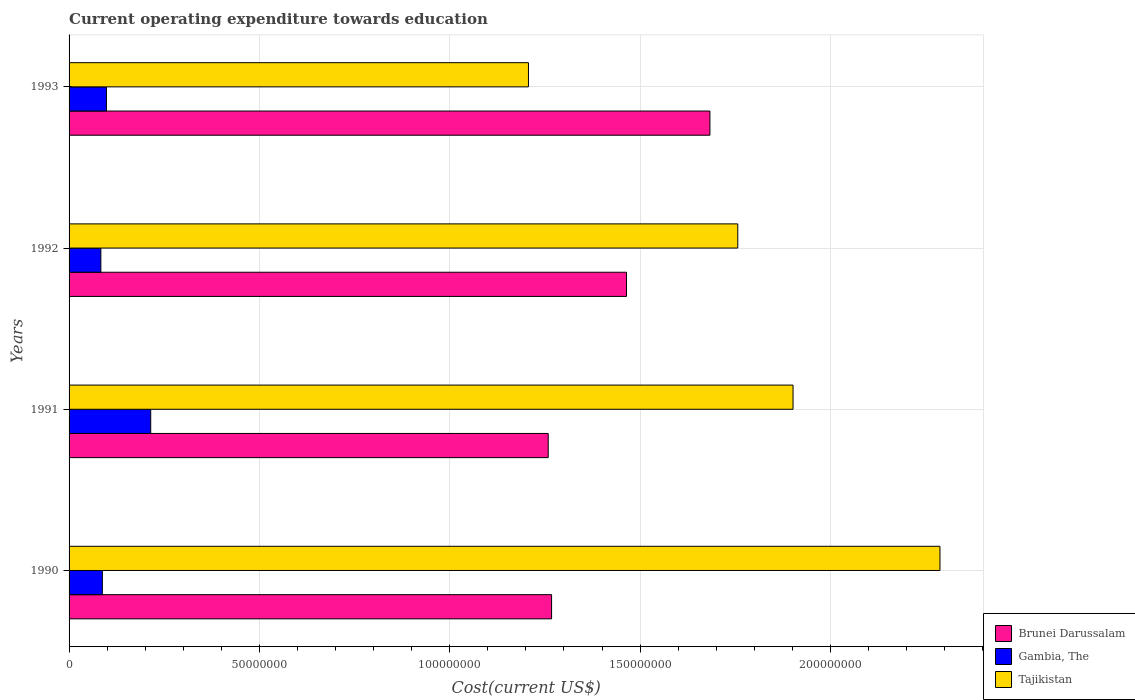What is the label of the 3rd group of bars from the top?
Provide a succinct answer. 1991. What is the expenditure towards education in Gambia, The in 1993?
Keep it short and to the point. 9.81e+06. Across all years, what is the maximum expenditure towards education in Gambia, The?
Provide a succinct answer. 2.14e+07. Across all years, what is the minimum expenditure towards education in Brunei Darussalam?
Offer a very short reply. 1.26e+08. In which year was the expenditure towards education in Brunei Darussalam maximum?
Offer a very short reply. 1993. What is the total expenditure towards education in Tajikistan in the graph?
Make the answer very short. 7.15e+08. What is the difference between the expenditure towards education in Brunei Darussalam in 1991 and that in 1992?
Give a very brief answer. -2.06e+07. What is the difference between the expenditure towards education in Gambia, The in 1992 and the expenditure towards education in Tajikistan in 1991?
Your answer should be very brief. -1.82e+08. What is the average expenditure towards education in Gambia, The per year?
Make the answer very short. 1.21e+07. In the year 1991, what is the difference between the expenditure towards education in Tajikistan and expenditure towards education in Brunei Darussalam?
Give a very brief answer. 6.43e+07. In how many years, is the expenditure towards education in Tajikistan greater than 70000000 US$?
Ensure brevity in your answer.  4. What is the ratio of the expenditure towards education in Brunei Darussalam in 1990 to that in 1991?
Your answer should be compact. 1.01. Is the difference between the expenditure towards education in Tajikistan in 1991 and 1992 greater than the difference between the expenditure towards education in Brunei Darussalam in 1991 and 1992?
Provide a short and direct response. Yes. What is the difference between the highest and the second highest expenditure towards education in Gambia, The?
Make the answer very short. 1.16e+07. What is the difference between the highest and the lowest expenditure towards education in Gambia, The?
Ensure brevity in your answer.  1.31e+07. What does the 1st bar from the top in 1992 represents?
Keep it short and to the point. Tajikistan. What does the 2nd bar from the bottom in 1992 represents?
Ensure brevity in your answer.  Gambia, The. Is it the case that in every year, the sum of the expenditure towards education in Tajikistan and expenditure towards education in Gambia, The is greater than the expenditure towards education in Brunei Darussalam?
Offer a very short reply. No. Does the graph contain any zero values?
Keep it short and to the point. No. Does the graph contain grids?
Keep it short and to the point. Yes. Where does the legend appear in the graph?
Ensure brevity in your answer.  Bottom right. How many legend labels are there?
Your answer should be very brief. 3. What is the title of the graph?
Your response must be concise. Current operating expenditure towards education. Does "Palau" appear as one of the legend labels in the graph?
Offer a very short reply. No. What is the label or title of the X-axis?
Provide a succinct answer. Cost(current US$). What is the Cost(current US$) in Brunei Darussalam in 1990?
Provide a succinct answer. 1.27e+08. What is the Cost(current US$) of Gambia, The in 1990?
Ensure brevity in your answer.  8.75e+06. What is the Cost(current US$) of Tajikistan in 1990?
Provide a succinct answer. 2.29e+08. What is the Cost(current US$) in Brunei Darussalam in 1991?
Your response must be concise. 1.26e+08. What is the Cost(current US$) of Gambia, The in 1991?
Your answer should be compact. 2.14e+07. What is the Cost(current US$) in Tajikistan in 1991?
Your answer should be compact. 1.90e+08. What is the Cost(current US$) in Brunei Darussalam in 1992?
Give a very brief answer. 1.46e+08. What is the Cost(current US$) of Gambia, The in 1992?
Offer a very short reply. 8.35e+06. What is the Cost(current US$) in Tajikistan in 1992?
Your response must be concise. 1.76e+08. What is the Cost(current US$) of Brunei Darussalam in 1993?
Keep it short and to the point. 1.68e+08. What is the Cost(current US$) of Gambia, The in 1993?
Your answer should be very brief. 9.81e+06. What is the Cost(current US$) of Tajikistan in 1993?
Ensure brevity in your answer.  1.21e+08. Across all years, what is the maximum Cost(current US$) in Brunei Darussalam?
Ensure brevity in your answer.  1.68e+08. Across all years, what is the maximum Cost(current US$) in Gambia, The?
Provide a short and direct response. 2.14e+07. Across all years, what is the maximum Cost(current US$) in Tajikistan?
Make the answer very short. 2.29e+08. Across all years, what is the minimum Cost(current US$) in Brunei Darussalam?
Keep it short and to the point. 1.26e+08. Across all years, what is the minimum Cost(current US$) in Gambia, The?
Keep it short and to the point. 8.35e+06. Across all years, what is the minimum Cost(current US$) in Tajikistan?
Offer a very short reply. 1.21e+08. What is the total Cost(current US$) in Brunei Darussalam in the graph?
Your answer should be compact. 5.67e+08. What is the total Cost(current US$) in Gambia, The in the graph?
Provide a succinct answer. 4.84e+07. What is the total Cost(current US$) in Tajikistan in the graph?
Keep it short and to the point. 7.15e+08. What is the difference between the Cost(current US$) of Brunei Darussalam in 1990 and that in 1991?
Offer a very short reply. 8.83e+05. What is the difference between the Cost(current US$) of Gambia, The in 1990 and that in 1991?
Give a very brief answer. -1.27e+07. What is the difference between the Cost(current US$) in Tajikistan in 1990 and that in 1991?
Provide a short and direct response. 3.86e+07. What is the difference between the Cost(current US$) of Brunei Darussalam in 1990 and that in 1992?
Give a very brief answer. -1.97e+07. What is the difference between the Cost(current US$) of Gambia, The in 1990 and that in 1992?
Give a very brief answer. 3.99e+05. What is the difference between the Cost(current US$) of Tajikistan in 1990 and that in 1992?
Make the answer very short. 5.31e+07. What is the difference between the Cost(current US$) in Brunei Darussalam in 1990 and that in 1993?
Keep it short and to the point. -4.16e+07. What is the difference between the Cost(current US$) of Gambia, The in 1990 and that in 1993?
Offer a terse response. -1.07e+06. What is the difference between the Cost(current US$) of Tajikistan in 1990 and that in 1993?
Provide a short and direct response. 1.08e+08. What is the difference between the Cost(current US$) of Brunei Darussalam in 1991 and that in 1992?
Make the answer very short. -2.06e+07. What is the difference between the Cost(current US$) of Gambia, The in 1991 and that in 1992?
Your answer should be very brief. 1.31e+07. What is the difference between the Cost(current US$) in Tajikistan in 1991 and that in 1992?
Provide a short and direct response. 1.45e+07. What is the difference between the Cost(current US$) in Brunei Darussalam in 1991 and that in 1993?
Ensure brevity in your answer.  -4.25e+07. What is the difference between the Cost(current US$) in Gambia, The in 1991 and that in 1993?
Provide a succinct answer. 1.16e+07. What is the difference between the Cost(current US$) of Tajikistan in 1991 and that in 1993?
Your response must be concise. 6.95e+07. What is the difference between the Cost(current US$) in Brunei Darussalam in 1992 and that in 1993?
Provide a short and direct response. -2.19e+07. What is the difference between the Cost(current US$) of Gambia, The in 1992 and that in 1993?
Your answer should be very brief. -1.47e+06. What is the difference between the Cost(current US$) in Tajikistan in 1992 and that in 1993?
Keep it short and to the point. 5.50e+07. What is the difference between the Cost(current US$) in Brunei Darussalam in 1990 and the Cost(current US$) in Gambia, The in 1991?
Give a very brief answer. 1.05e+08. What is the difference between the Cost(current US$) of Brunei Darussalam in 1990 and the Cost(current US$) of Tajikistan in 1991?
Make the answer very short. -6.34e+07. What is the difference between the Cost(current US$) of Gambia, The in 1990 and the Cost(current US$) of Tajikistan in 1991?
Ensure brevity in your answer.  -1.81e+08. What is the difference between the Cost(current US$) in Brunei Darussalam in 1990 and the Cost(current US$) in Gambia, The in 1992?
Your answer should be compact. 1.18e+08. What is the difference between the Cost(current US$) of Brunei Darussalam in 1990 and the Cost(current US$) of Tajikistan in 1992?
Provide a succinct answer. -4.89e+07. What is the difference between the Cost(current US$) of Gambia, The in 1990 and the Cost(current US$) of Tajikistan in 1992?
Offer a very short reply. -1.67e+08. What is the difference between the Cost(current US$) of Brunei Darussalam in 1990 and the Cost(current US$) of Gambia, The in 1993?
Provide a short and direct response. 1.17e+08. What is the difference between the Cost(current US$) of Brunei Darussalam in 1990 and the Cost(current US$) of Tajikistan in 1993?
Ensure brevity in your answer.  6.07e+06. What is the difference between the Cost(current US$) of Gambia, The in 1990 and the Cost(current US$) of Tajikistan in 1993?
Give a very brief answer. -1.12e+08. What is the difference between the Cost(current US$) of Brunei Darussalam in 1991 and the Cost(current US$) of Gambia, The in 1992?
Give a very brief answer. 1.18e+08. What is the difference between the Cost(current US$) in Brunei Darussalam in 1991 and the Cost(current US$) in Tajikistan in 1992?
Offer a terse response. -4.98e+07. What is the difference between the Cost(current US$) of Gambia, The in 1991 and the Cost(current US$) of Tajikistan in 1992?
Your answer should be very brief. -1.54e+08. What is the difference between the Cost(current US$) in Brunei Darussalam in 1991 and the Cost(current US$) in Gambia, The in 1993?
Give a very brief answer. 1.16e+08. What is the difference between the Cost(current US$) in Brunei Darussalam in 1991 and the Cost(current US$) in Tajikistan in 1993?
Your answer should be very brief. 5.19e+06. What is the difference between the Cost(current US$) in Gambia, The in 1991 and the Cost(current US$) in Tajikistan in 1993?
Keep it short and to the point. -9.92e+07. What is the difference between the Cost(current US$) of Brunei Darussalam in 1992 and the Cost(current US$) of Gambia, The in 1993?
Give a very brief answer. 1.37e+08. What is the difference between the Cost(current US$) of Brunei Darussalam in 1992 and the Cost(current US$) of Tajikistan in 1993?
Your answer should be compact. 2.58e+07. What is the difference between the Cost(current US$) in Gambia, The in 1992 and the Cost(current US$) in Tajikistan in 1993?
Offer a very short reply. -1.12e+08. What is the average Cost(current US$) in Brunei Darussalam per year?
Provide a short and direct response. 1.42e+08. What is the average Cost(current US$) in Gambia, The per year?
Your answer should be compact. 1.21e+07. What is the average Cost(current US$) of Tajikistan per year?
Provide a succinct answer. 1.79e+08. In the year 1990, what is the difference between the Cost(current US$) of Brunei Darussalam and Cost(current US$) of Gambia, The?
Your answer should be compact. 1.18e+08. In the year 1990, what is the difference between the Cost(current US$) of Brunei Darussalam and Cost(current US$) of Tajikistan?
Offer a very short reply. -1.02e+08. In the year 1990, what is the difference between the Cost(current US$) of Gambia, The and Cost(current US$) of Tajikistan?
Your answer should be very brief. -2.20e+08. In the year 1991, what is the difference between the Cost(current US$) of Brunei Darussalam and Cost(current US$) of Gambia, The?
Offer a terse response. 1.04e+08. In the year 1991, what is the difference between the Cost(current US$) in Brunei Darussalam and Cost(current US$) in Tajikistan?
Give a very brief answer. -6.43e+07. In the year 1991, what is the difference between the Cost(current US$) in Gambia, The and Cost(current US$) in Tajikistan?
Provide a short and direct response. -1.69e+08. In the year 1992, what is the difference between the Cost(current US$) in Brunei Darussalam and Cost(current US$) in Gambia, The?
Make the answer very short. 1.38e+08. In the year 1992, what is the difference between the Cost(current US$) in Brunei Darussalam and Cost(current US$) in Tajikistan?
Keep it short and to the point. -2.92e+07. In the year 1992, what is the difference between the Cost(current US$) in Gambia, The and Cost(current US$) in Tajikistan?
Provide a short and direct response. -1.67e+08. In the year 1993, what is the difference between the Cost(current US$) in Brunei Darussalam and Cost(current US$) in Gambia, The?
Your response must be concise. 1.59e+08. In the year 1993, what is the difference between the Cost(current US$) of Brunei Darussalam and Cost(current US$) of Tajikistan?
Provide a succinct answer. 4.77e+07. In the year 1993, what is the difference between the Cost(current US$) of Gambia, The and Cost(current US$) of Tajikistan?
Offer a very short reply. -1.11e+08. What is the ratio of the Cost(current US$) in Gambia, The in 1990 to that in 1991?
Give a very brief answer. 0.41. What is the ratio of the Cost(current US$) of Tajikistan in 1990 to that in 1991?
Give a very brief answer. 1.2. What is the ratio of the Cost(current US$) in Brunei Darussalam in 1990 to that in 1992?
Your answer should be compact. 0.87. What is the ratio of the Cost(current US$) of Gambia, The in 1990 to that in 1992?
Keep it short and to the point. 1.05. What is the ratio of the Cost(current US$) of Tajikistan in 1990 to that in 1992?
Offer a very short reply. 1.3. What is the ratio of the Cost(current US$) of Brunei Darussalam in 1990 to that in 1993?
Provide a short and direct response. 0.75. What is the ratio of the Cost(current US$) in Gambia, The in 1990 to that in 1993?
Give a very brief answer. 0.89. What is the ratio of the Cost(current US$) in Tajikistan in 1990 to that in 1993?
Make the answer very short. 1.9. What is the ratio of the Cost(current US$) in Brunei Darussalam in 1991 to that in 1992?
Provide a succinct answer. 0.86. What is the ratio of the Cost(current US$) of Gambia, The in 1991 to that in 1992?
Ensure brevity in your answer.  2.57. What is the ratio of the Cost(current US$) of Tajikistan in 1991 to that in 1992?
Keep it short and to the point. 1.08. What is the ratio of the Cost(current US$) in Brunei Darussalam in 1991 to that in 1993?
Ensure brevity in your answer.  0.75. What is the ratio of the Cost(current US$) of Gambia, The in 1991 to that in 1993?
Ensure brevity in your answer.  2.19. What is the ratio of the Cost(current US$) of Tajikistan in 1991 to that in 1993?
Give a very brief answer. 1.58. What is the ratio of the Cost(current US$) in Brunei Darussalam in 1992 to that in 1993?
Provide a succinct answer. 0.87. What is the ratio of the Cost(current US$) of Gambia, The in 1992 to that in 1993?
Your answer should be compact. 0.85. What is the ratio of the Cost(current US$) in Tajikistan in 1992 to that in 1993?
Provide a short and direct response. 1.46. What is the difference between the highest and the second highest Cost(current US$) of Brunei Darussalam?
Make the answer very short. 2.19e+07. What is the difference between the highest and the second highest Cost(current US$) in Gambia, The?
Keep it short and to the point. 1.16e+07. What is the difference between the highest and the second highest Cost(current US$) of Tajikistan?
Make the answer very short. 3.86e+07. What is the difference between the highest and the lowest Cost(current US$) of Brunei Darussalam?
Offer a terse response. 4.25e+07. What is the difference between the highest and the lowest Cost(current US$) of Gambia, The?
Your answer should be compact. 1.31e+07. What is the difference between the highest and the lowest Cost(current US$) of Tajikistan?
Provide a short and direct response. 1.08e+08. 